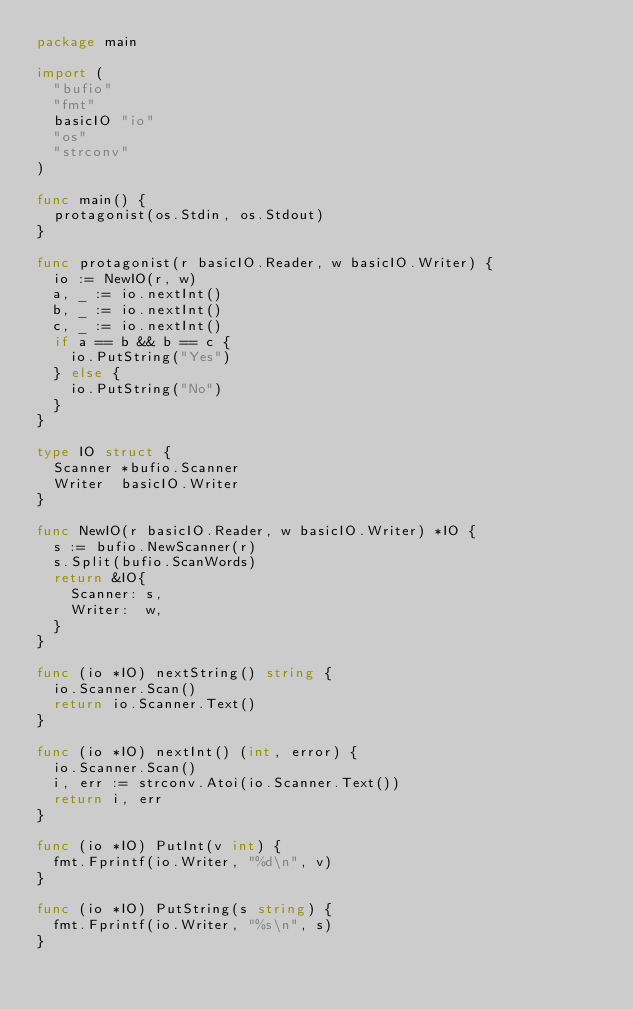Convert code to text. <code><loc_0><loc_0><loc_500><loc_500><_Go_>package main

import (
	"bufio"
	"fmt"
	basicIO "io"
	"os"
	"strconv"
)

func main() {
	protagonist(os.Stdin, os.Stdout)
}

func protagonist(r basicIO.Reader, w basicIO.Writer) {
	io := NewIO(r, w)
	a, _ := io.nextInt()
	b, _ := io.nextInt()
	c, _ := io.nextInt()
	if a == b && b == c {
		io.PutString("Yes")
	} else {
		io.PutString("No")
	}
}

type IO struct {
	Scanner *bufio.Scanner
	Writer  basicIO.Writer
}

func NewIO(r basicIO.Reader, w basicIO.Writer) *IO {
	s := bufio.NewScanner(r)
	s.Split(bufio.ScanWords)
	return &IO{
		Scanner: s,
		Writer:  w,
	}
}

func (io *IO) nextString() string {
	io.Scanner.Scan()
	return io.Scanner.Text()
}

func (io *IO) nextInt() (int, error) {
	io.Scanner.Scan()
	i, err := strconv.Atoi(io.Scanner.Text())
	return i, err
}

func (io *IO) PutInt(v int) {
	fmt.Fprintf(io.Writer, "%d\n", v)
}

func (io *IO) PutString(s string) {
	fmt.Fprintf(io.Writer, "%s\n", s)
}
</code> 